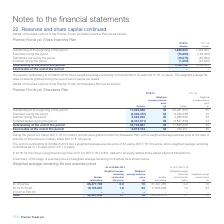According to Premier Foods Plc's financial document, What was the amount of options granted under the Sharesave plan? According to the financial document, 5.0 million. The relevant text states: "During the period 5.0 million (2017/18: 5.0 million) options were granted under the Sharesave Plan, with a weighted average exerc During the period 5.0 million (2017/18: 5.0 million) options were gran..." Also, What was the weighted average exercise price of outstanding options at 30 March 2019? According to the financial document, 32 pence. The relevant text states: "rch 2019 had a weighted average exercise price of 32 pence (2017/18: 33 pence), and a weighted average remaining contractual life of 1.6 years (2017/18: 1.6 y..." Also, What was the expense recognised in 2018/19? According to the financial document, £2.1m. The relevant text states: "In 2018/19, the Group recognised an expense of £2.1m (2017/18: £2.8m), related to all equity-settled share-based payment transactions...." Also, can you calculate: What was the change in the Outstanding at the beginning of the period for options from 2017/18 to 2018/19? Based on the calculation: 17,835,628 - 20,231,334, the result is -2395706. This is based on the information: "ce (p) Outstanding at the beginning of the period 17,835,628 33 20,231,334 35 Exercised during the period (4,306,470) 32 (3,536,539) 34 Granted during the perio ding at the beginning of the period 17,..." The key data points involved are: 17,835,628, 20,231,334. Also, can you calculate: What is the change in the Exercised during the period weighted average exercise price from 2017/18 to 2018/19? Based on the calculation: 32 - 34, the result is -2. This is based on the information: "ised during the period (4,306,470) 32 (3,536,539) 34 Granted during the period 5,022,240 30 4,988,669 33 Forfeited/lapsed during the period (2,447,511) 31,334 35 Exercised during the period (4,306,470..." The key data points involved are: 32, 34. Also, can you calculate: What is the change in options granted between 2017/18 and 2018/19? Based on the calculation: 5,022,240 - 4,988,669, the result is 33571. This is based on the information: "36,539) 34 Granted during the period 5,022,240 30 4,988,669 33 Forfeited/lapsed during the period (2,447,511) 33 (3,847,836) 44 ,470) 32 (3,536,539) 34 Granted during the period 5,022,240 30 4,988,669..." The key data points involved are: 4,988,669, 5,022,240. 